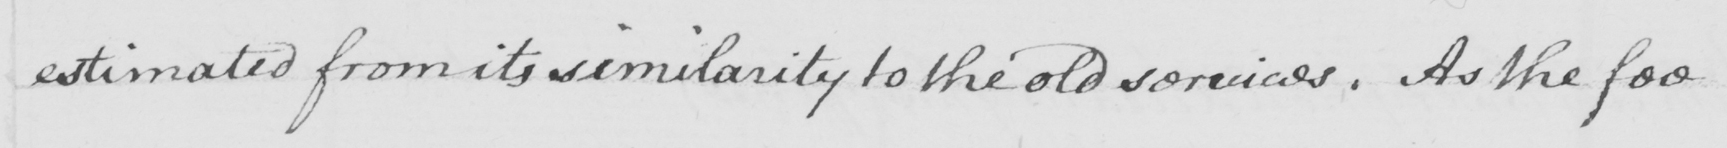Can you tell me what this handwritten text says? estimated from its similarity to the old services . As the fee 